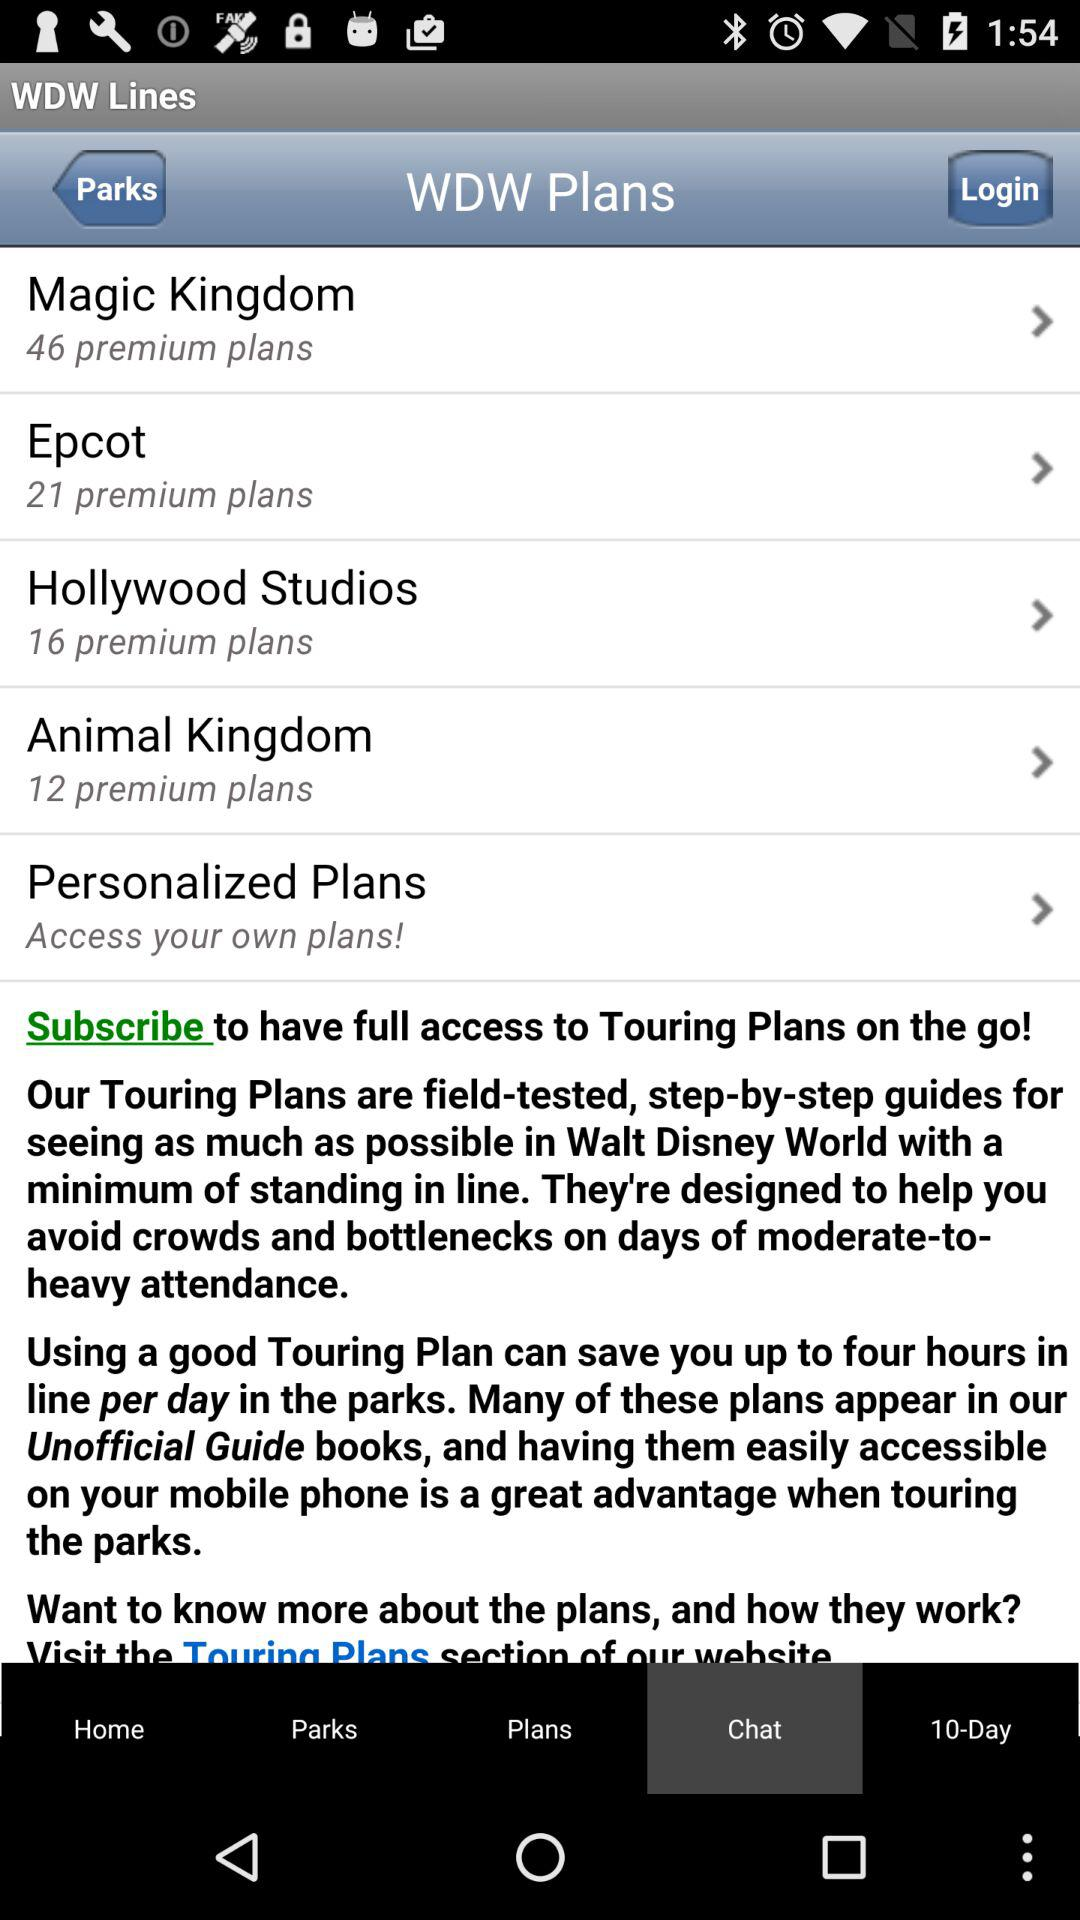Which option is selected in the "WDW Plans"? The selected option is "Chat". 